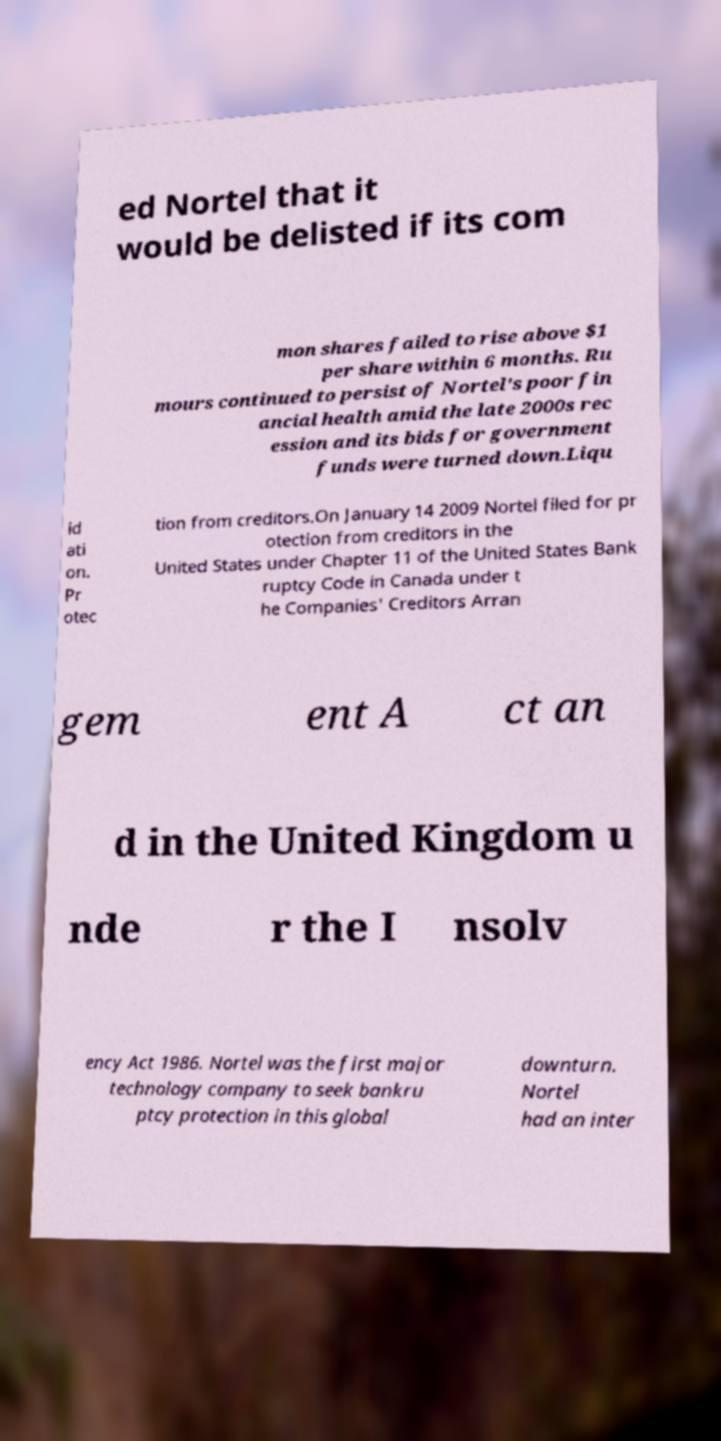Could you extract and type out the text from this image? ed Nortel that it would be delisted if its com mon shares failed to rise above $1 per share within 6 months. Ru mours continued to persist of Nortel's poor fin ancial health amid the late 2000s rec ession and its bids for government funds were turned down.Liqu id ati on. Pr otec tion from creditors.On January 14 2009 Nortel filed for pr otection from creditors in the United States under Chapter 11 of the United States Bank ruptcy Code in Canada under t he Companies' Creditors Arran gem ent A ct an d in the United Kingdom u nde r the I nsolv ency Act 1986. Nortel was the first major technology company to seek bankru ptcy protection in this global downturn. Nortel had an inter 